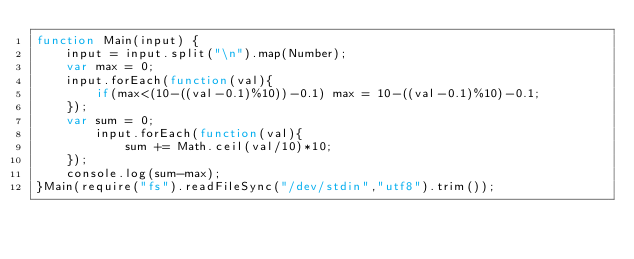Convert code to text. <code><loc_0><loc_0><loc_500><loc_500><_JavaScript_>function Main(input) {
    input = input.split("\n").map(Number);
    var max = 0;
    input.forEach(function(val){
        if(max<(10-((val-0.1)%10))-0.1) max = 10-((val-0.1)%10)-0.1;
    });
    var sum = 0;
        input.forEach(function(val){
            sum += Math.ceil(val/10)*10;
    });
    console.log(sum-max);
}Main(require("fs").readFileSync("/dev/stdin","utf8").trim());
</code> 